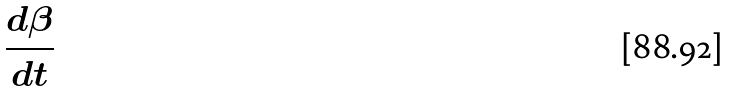<formula> <loc_0><loc_0><loc_500><loc_500>\frac { d \beta } { d t }</formula> 